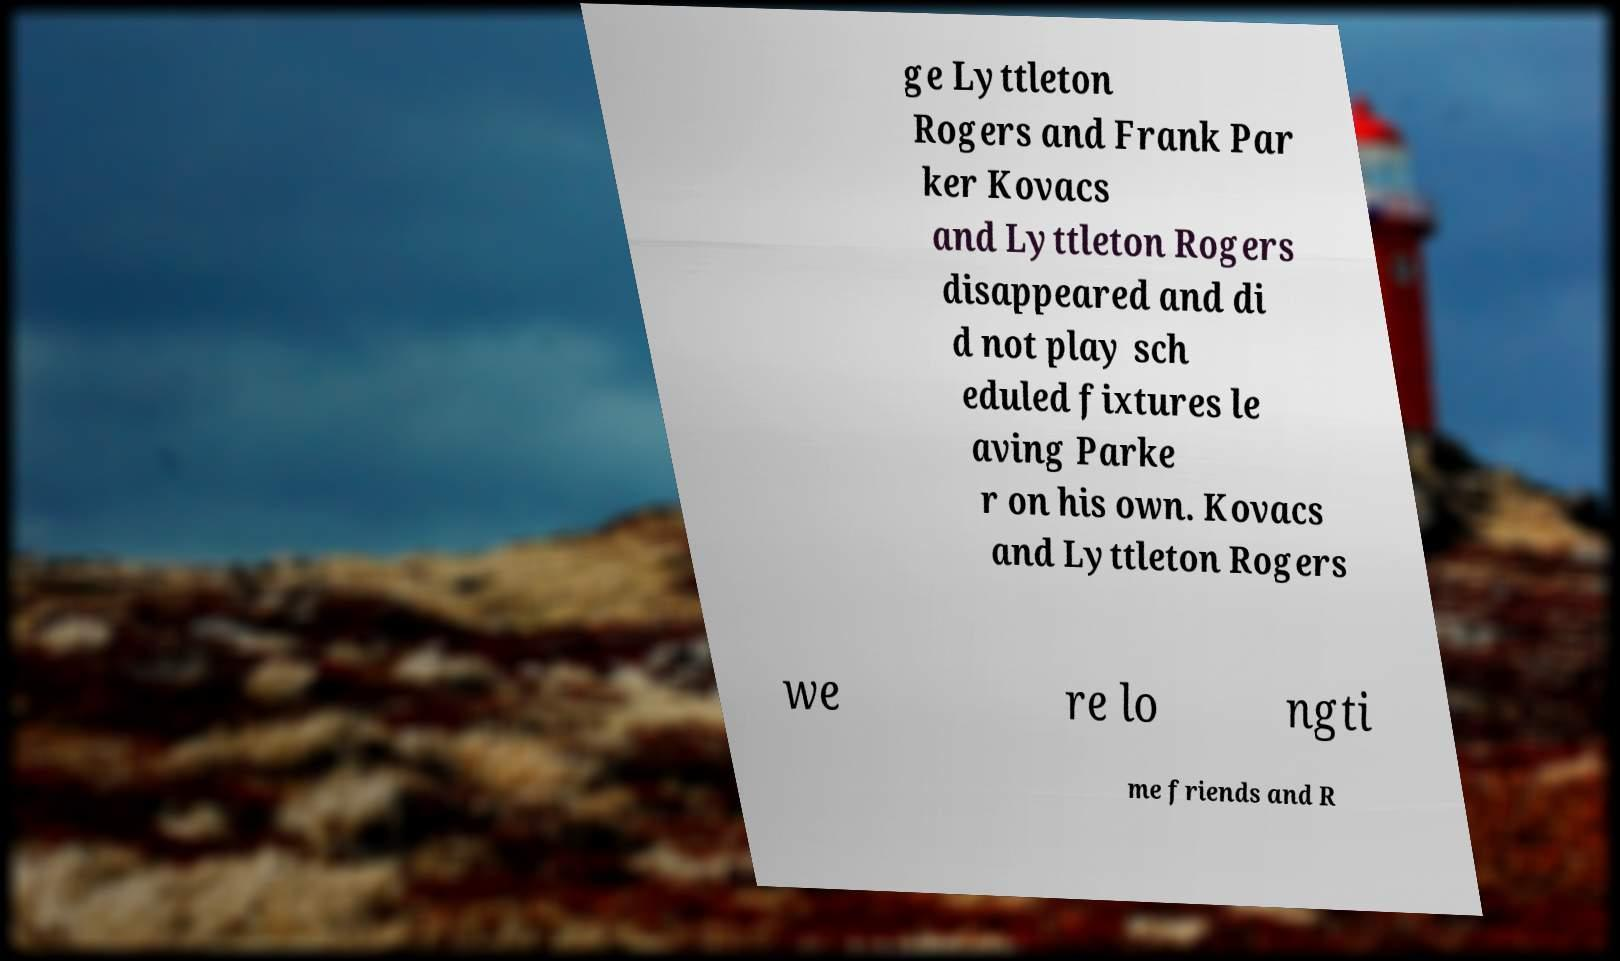There's text embedded in this image that I need extracted. Can you transcribe it verbatim? ge Lyttleton Rogers and Frank Par ker Kovacs and Lyttleton Rogers disappeared and di d not play sch eduled fixtures le aving Parke r on his own. Kovacs and Lyttleton Rogers we re lo ngti me friends and R 